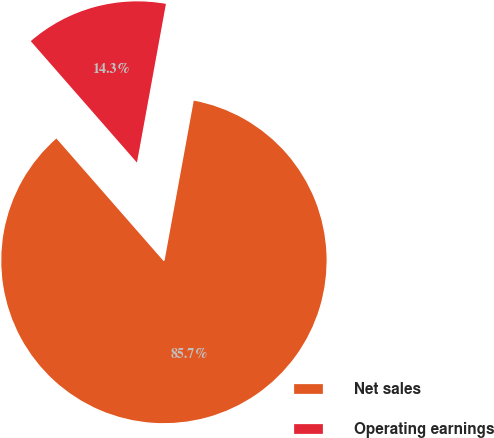Convert chart to OTSL. <chart><loc_0><loc_0><loc_500><loc_500><pie_chart><fcel>Net sales<fcel>Operating earnings<nl><fcel>85.69%<fcel>14.31%<nl></chart> 